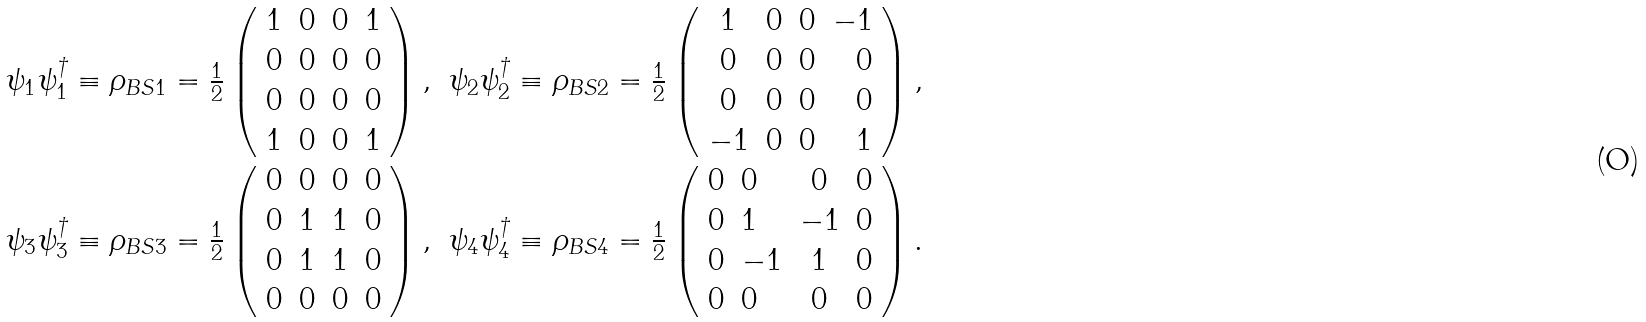<formula> <loc_0><loc_0><loc_500><loc_500>\begin{array} { c r c r } \psi _ { 1 } \psi _ { 1 } ^ { \dagger } \equiv \rho _ { B S 1 } = \frac { 1 } { 2 } \left ( \begin{array} { c c c c } 1 & 0 & 0 & 1 \\ 0 & 0 & 0 & 0 \\ 0 & 0 & 0 & 0 \\ 1 & 0 & 0 & 1 \end{array} \right ) , & \psi _ { 2 } \psi _ { 2 } ^ { \dagger } \equiv \rho _ { B S 2 } = \frac { 1 } { 2 } \left ( \begin{array} { c r c r } 1 & 0 & 0 & - 1 \\ 0 & 0 & 0 & 0 \\ 0 & 0 & 0 & 0 \\ - 1 & 0 & 0 & 1 \end{array} \right ) , \\ \psi _ { 3 } \psi _ { 3 } ^ { \dagger } \equiv \rho _ { B S 3 } = \frac { 1 } { 2 } \left ( \begin{array} { c r c r } 0 & 0 & 0 & 0 \\ 0 & 1 & 1 & 0 \\ 0 & 1 & 1 & 0 \\ 0 & 0 & 0 & 0 \end{array} \right ) , & \psi _ { 4 } \psi _ { 4 } ^ { \dagger } \equiv \rho _ { B S 4 } = \frac { 1 } { 2 } \left ( \begin{array} { c l c r } 0 & 0 & 0 & 0 \\ 0 & 1 & - 1 & 0 \\ 0 & - 1 & 1 & 0 \\ 0 & 0 & 0 & 0 \end{array} \right ) . \\ \end{array}</formula> 